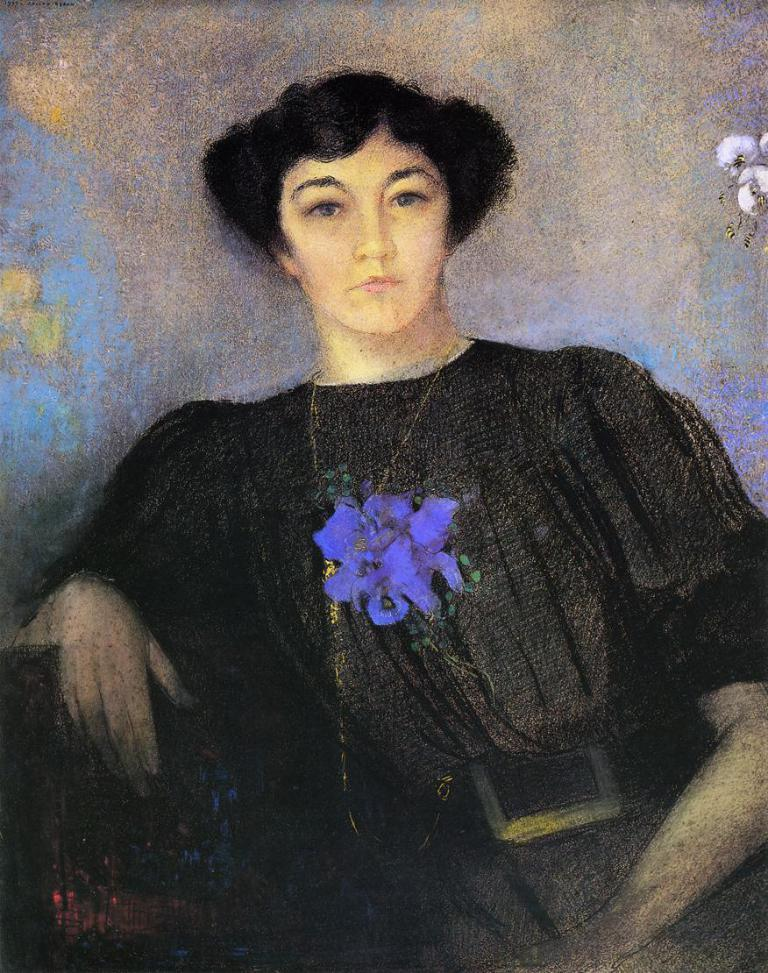What type of artwork is depicted on the wall in the image? There is an art of a person and an art of birds on the wall. Can you describe the subjects of the artwork? The artwork features a person and birds. What type of furniture is visible in the image? There is no furniture visible in the image; it only features artwork on the wall. What color are the trousers worn by the person in the artwork? The provided facts do not mention the color of the trousers worn by the person in the artwork, as the focus is on the subjects of the artwork. 